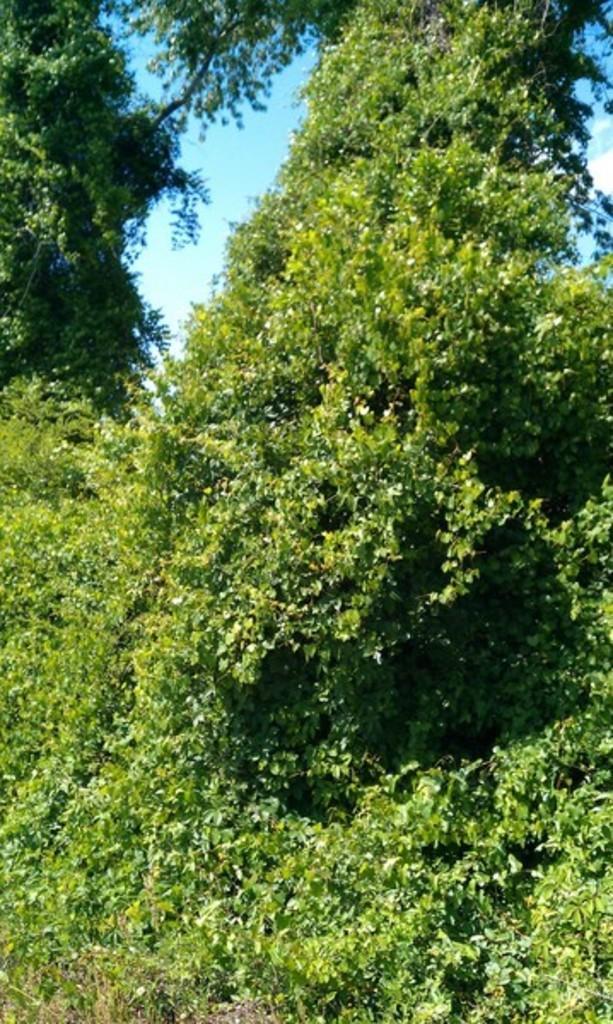Can you describe this image briefly? In the image in the center, we can see the sky, clouds and trees. 